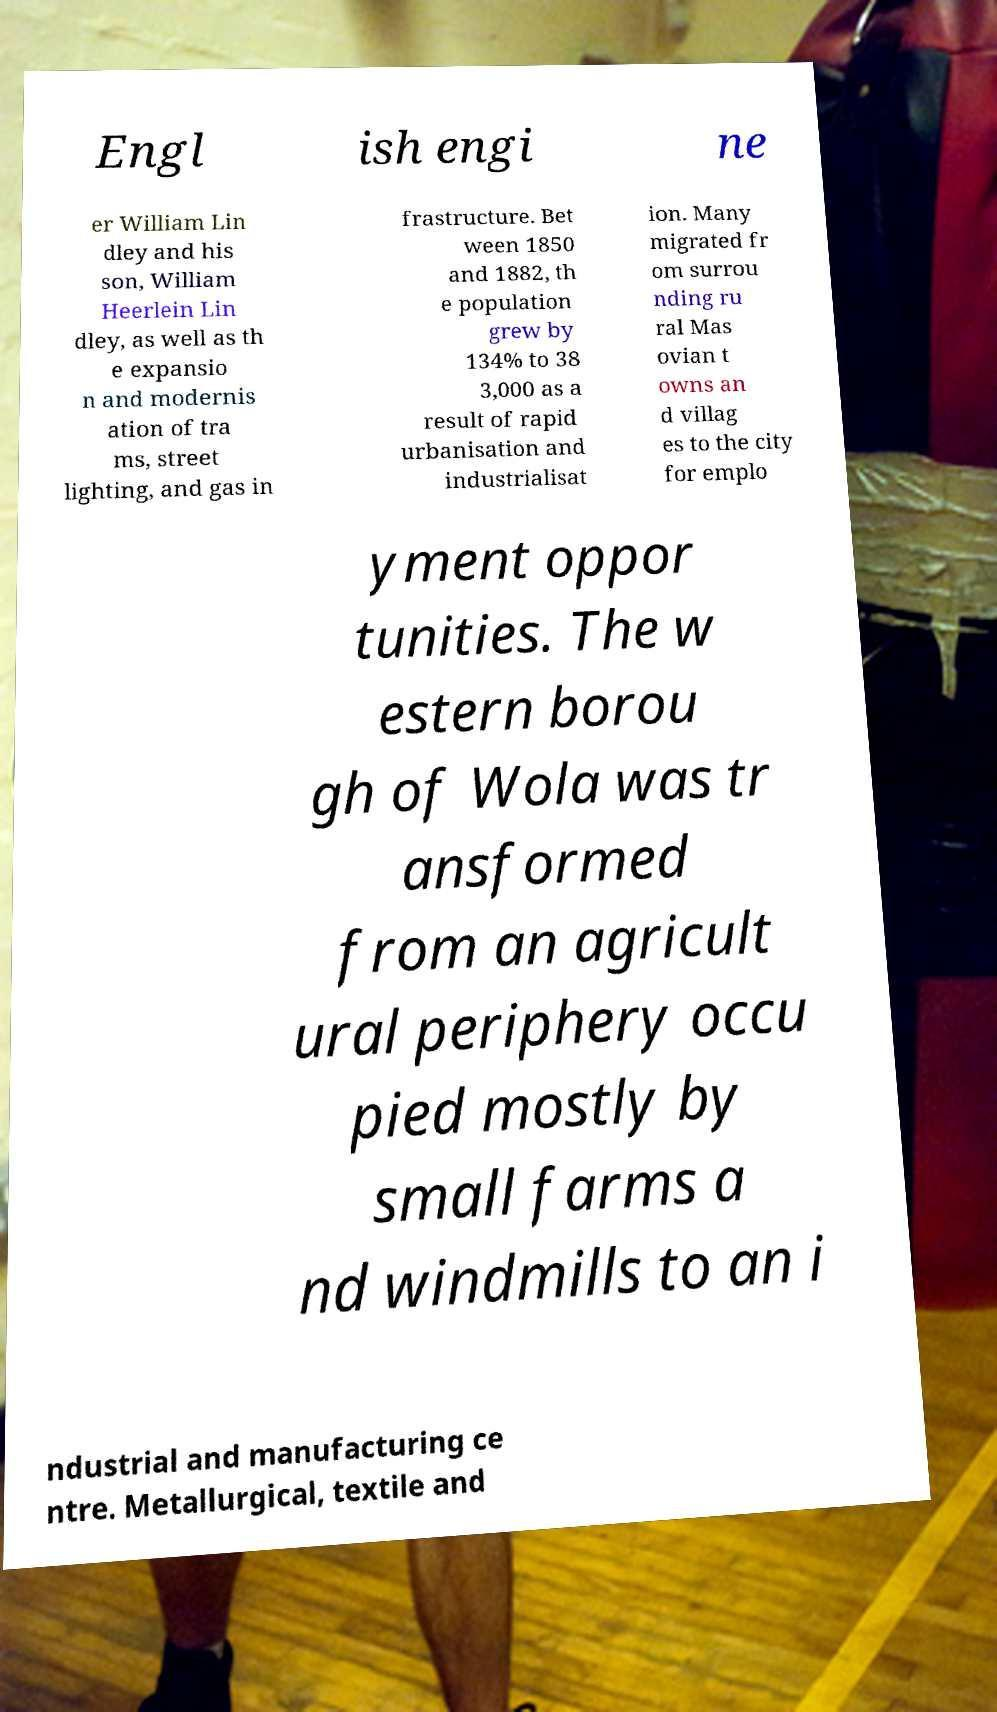Please identify and transcribe the text found in this image. Engl ish engi ne er William Lin dley and his son, William Heerlein Lin dley, as well as th e expansio n and modernis ation of tra ms, street lighting, and gas in frastructure. Bet ween 1850 and 1882, th e population grew by 134% to 38 3,000 as a result of rapid urbanisation and industrialisat ion. Many migrated fr om surrou nding ru ral Mas ovian t owns an d villag es to the city for emplo yment oppor tunities. The w estern borou gh of Wola was tr ansformed from an agricult ural periphery occu pied mostly by small farms a nd windmills to an i ndustrial and manufacturing ce ntre. Metallurgical, textile and 